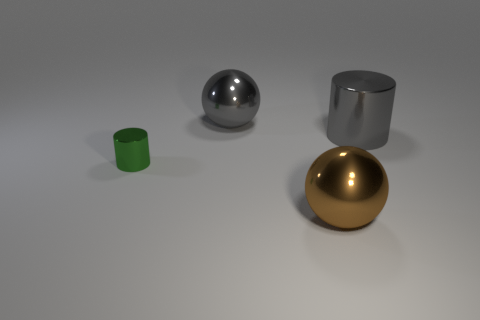Add 2 large red balls. How many objects exist? 6 Subtract all brown spheres. How many spheres are left? 1 Subtract 1 spheres. How many spheres are left? 1 Subtract all blue spheres. Subtract all green cubes. How many spheres are left? 2 Subtract all small yellow spheres. Subtract all big gray shiny cylinders. How many objects are left? 3 Add 3 small green cylinders. How many small green cylinders are left? 4 Add 4 big gray cylinders. How many big gray cylinders exist? 5 Subtract 0 cyan cylinders. How many objects are left? 4 